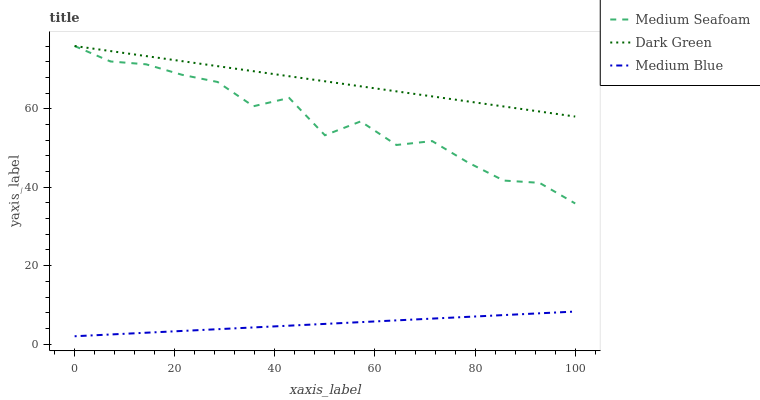Does Medium Blue have the minimum area under the curve?
Answer yes or no. Yes. Does Dark Green have the maximum area under the curve?
Answer yes or no. Yes. Does Medium Seafoam have the minimum area under the curve?
Answer yes or no. No. Does Medium Seafoam have the maximum area under the curve?
Answer yes or no. No. Is Medium Blue the smoothest?
Answer yes or no. Yes. Is Medium Seafoam the roughest?
Answer yes or no. Yes. Is Dark Green the smoothest?
Answer yes or no. No. Is Dark Green the roughest?
Answer yes or no. No. Does Medium Blue have the lowest value?
Answer yes or no. Yes. Does Medium Seafoam have the lowest value?
Answer yes or no. No. Does Dark Green have the highest value?
Answer yes or no. Yes. Is Medium Blue less than Medium Seafoam?
Answer yes or no. Yes. Is Medium Seafoam greater than Medium Blue?
Answer yes or no. Yes. Does Medium Seafoam intersect Dark Green?
Answer yes or no. Yes. Is Medium Seafoam less than Dark Green?
Answer yes or no. No. Is Medium Seafoam greater than Dark Green?
Answer yes or no. No. Does Medium Blue intersect Medium Seafoam?
Answer yes or no. No. 